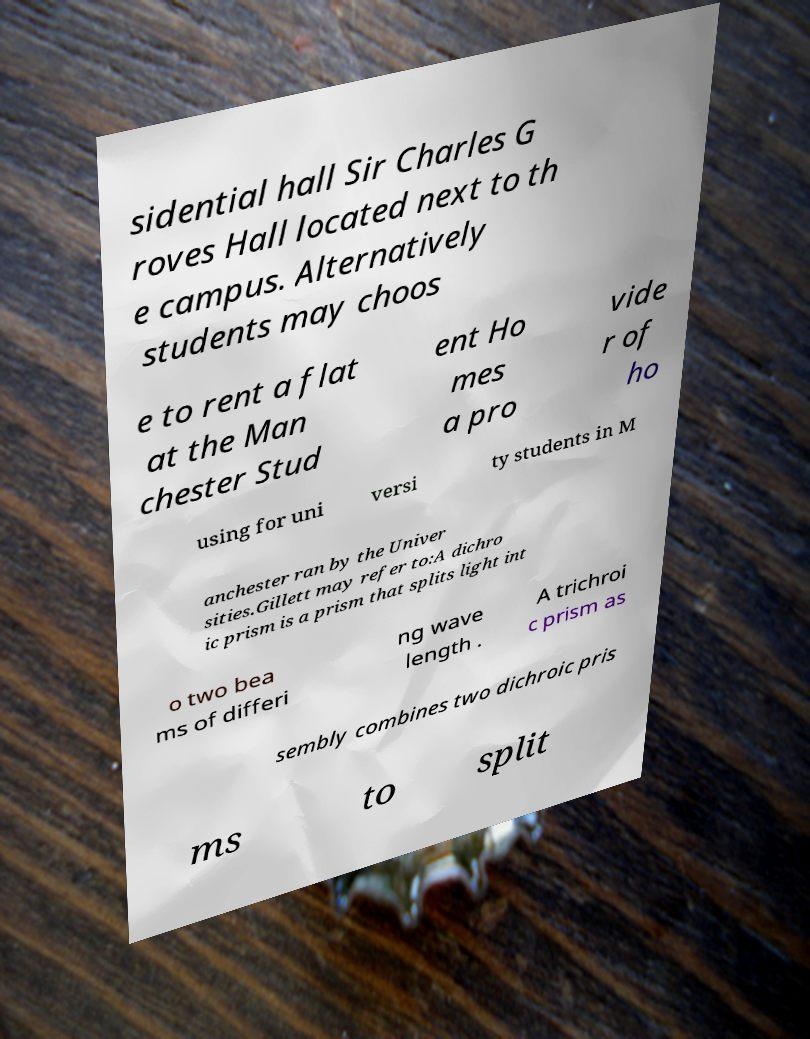Could you extract and type out the text from this image? sidential hall Sir Charles G roves Hall located next to th e campus. Alternatively students may choos e to rent a flat at the Man chester Stud ent Ho mes a pro vide r of ho using for uni versi ty students in M anchester ran by the Univer sities.Gillett may refer to:A dichro ic prism is a prism that splits light int o two bea ms of differi ng wave length . A trichroi c prism as sembly combines two dichroic pris ms to split 